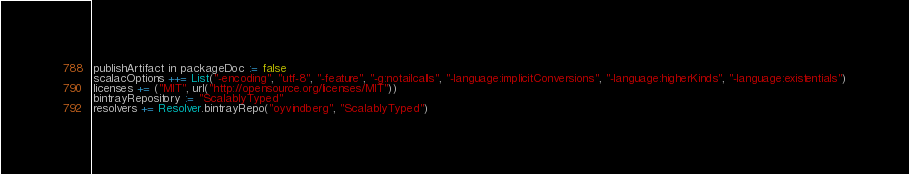Convert code to text. <code><loc_0><loc_0><loc_500><loc_500><_Scala_>publishArtifact in packageDoc := false
scalacOptions ++= List("-encoding", "utf-8", "-feature", "-g:notailcalls", "-language:implicitConversions", "-language:higherKinds", "-language:existentials")
licenses += ("MIT", url("http://opensource.org/licenses/MIT"))
bintrayRepository := "ScalablyTyped"
resolvers += Resolver.bintrayRepo("oyvindberg", "ScalablyTyped")
</code> 